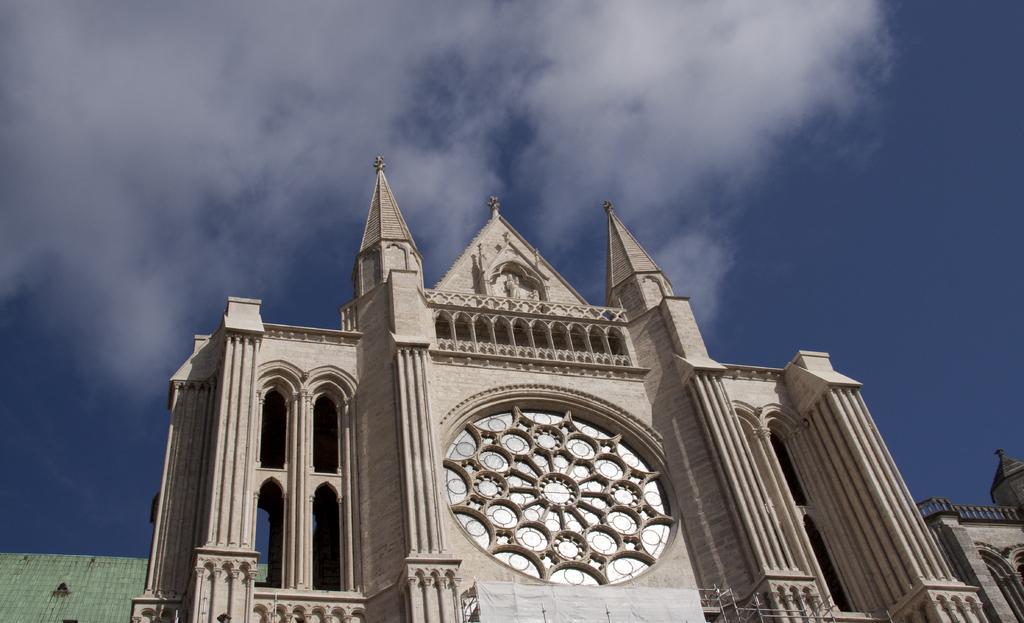Can you describe this image briefly? In this image I can see there is a building and it has some sculpture. The sky is clear. 